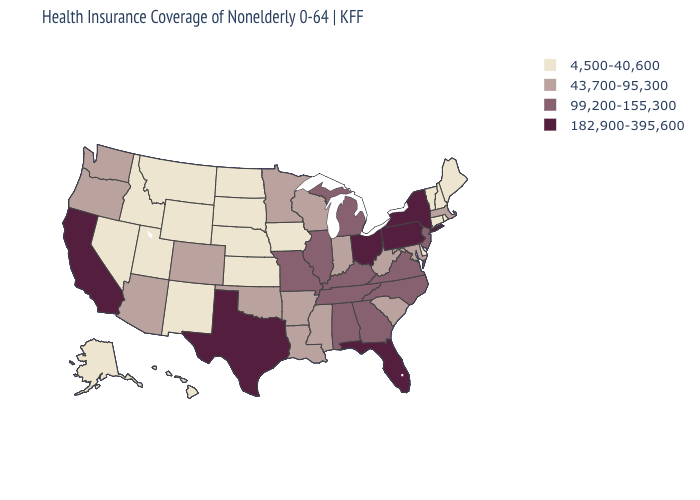What is the value of Kansas?
Give a very brief answer. 4,500-40,600. What is the value of Wisconsin?
Quick response, please. 43,700-95,300. Name the states that have a value in the range 43,700-95,300?
Keep it brief. Arizona, Arkansas, Colorado, Indiana, Louisiana, Maryland, Massachusetts, Minnesota, Mississippi, Oklahoma, Oregon, South Carolina, Washington, West Virginia, Wisconsin. Does Oregon have the highest value in the West?
Concise answer only. No. Does Missouri have a lower value than Nevada?
Quick response, please. No. Name the states that have a value in the range 4,500-40,600?
Write a very short answer. Alaska, Connecticut, Delaware, Hawaii, Idaho, Iowa, Kansas, Maine, Montana, Nebraska, Nevada, New Hampshire, New Mexico, North Dakota, Rhode Island, South Dakota, Utah, Vermont, Wyoming. Does the map have missing data?
Short answer required. No. Does Pennsylvania have the highest value in the USA?
Write a very short answer. Yes. Name the states that have a value in the range 182,900-395,600?
Quick response, please. California, Florida, New York, Ohio, Pennsylvania, Texas. Which states have the highest value in the USA?
Short answer required. California, Florida, New York, Ohio, Pennsylvania, Texas. What is the value of Illinois?
Be succinct. 99,200-155,300. Does the first symbol in the legend represent the smallest category?
Give a very brief answer. Yes. Does the first symbol in the legend represent the smallest category?
Concise answer only. Yes. Does California have the highest value in the West?
Short answer required. Yes. What is the value of New Hampshire?
Quick response, please. 4,500-40,600. 